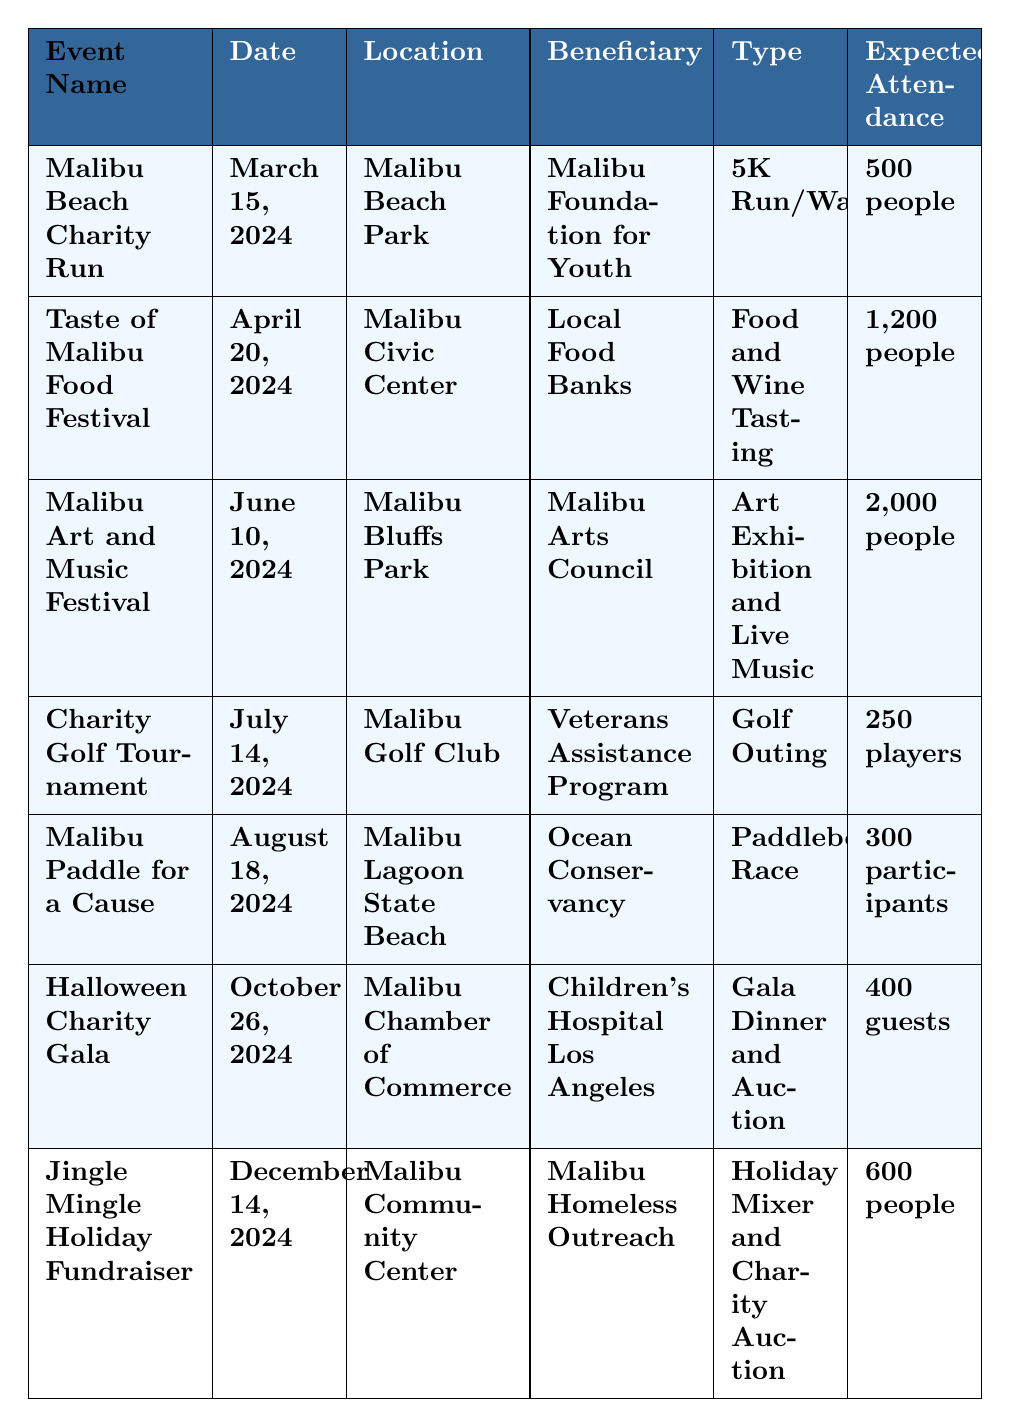What is the date of the Malibu Beach Charity Run? The table lists the Malibu Beach Charity Run under the "Event Name" column, and the corresponding date is found in the same row under the "Date" column, which is March 15, 2024.
Answer: March 15, 2024 How many people are expected to attend the Malibu Art and Music Festival? By locating the row for the Malibu Art and Music Festival in the table, we can see that the expected attendance, indicated in the "Expected Attendance" column, is 2,000 people.
Answer: 2,000 people Which event has the highest expected attendance? To determine this, we compare the values in the "Expected Attendance" column for all events. The Malibu Art and Music Festival has the highest figure, which is 2,000 people.
Answer: Malibu Art and Music Festival What type of event is scheduled for April 20, 2024? Looking at the "Date" column, we find April 20, 2024, corresponds to the "Taste of Malibu Food Festival" listed in the "Event Name" column. The "Type" column shows it is a Food and Wine Tasting event.
Answer: Food and Wine Tasting Is the Charity Golf Tournament benefitting the Malibu Foundation for Youth? Checking the "Beneficiary" column for the Charity Golf Tournament, we see that it is actually benefitting the Veterans Assistance Program, not the Malibu Foundation for Youth.
Answer: No How many participants are expected at the Malibu Paddle for a Cause? By locating the relevant row for the Malibu Paddle for a Cause in the table, we find under the "Expected Attendance" column that there are 300 participants expected.
Answer: 300 participants What is the difference in expected attendance between the Taste of Malibu Food Festival and the Halloween Charity Gala? The expected attendance for the Taste of Malibu Food Festival is 1,200 people, while for the Halloween Charity Gala it's 400 guests. The difference is 1,200 - 400 = 800.
Answer: 800 Which event takes place at the Malibu Civic Center? From the "Location" column, we check which event is scheduled at the Malibu Civic Center, and we find that the Taste of Malibu Food Festival is the event listed there.
Answer: Taste of Malibu Food Festival If a person wants to attend the events in the summer, which two events should they consider? Considering events taking place in the summer months, the table lists the Malibu Art and Music Festival on June 10, 2024, and the Charity Golf Tournament on July 14, 2024.
Answer: Malibu Art and Music Festival and Charity Golf Tournament How many players are expected for the Charity Golf Tournament compared to participants in the Malibu Paddle for a Cause? The table states that the expected attendance for the Charity Golf Tournament is 250 players, while the Malibu Paddle for a Cause expects 300 participants. The difference is 300 - 250 = 50, so there are more participants in the Paddle for a Cause.
Answer: More participants in Paddle for a Cause What is the venue for the Jingle Mingle Holiday Fundraiser? The Jingle Mingle Holiday Fundraiser is listed under the "Event Name" and the corresponding venue is found in the "Location" column, which is the Malibu Community Center.
Answer: Malibu Community Center 